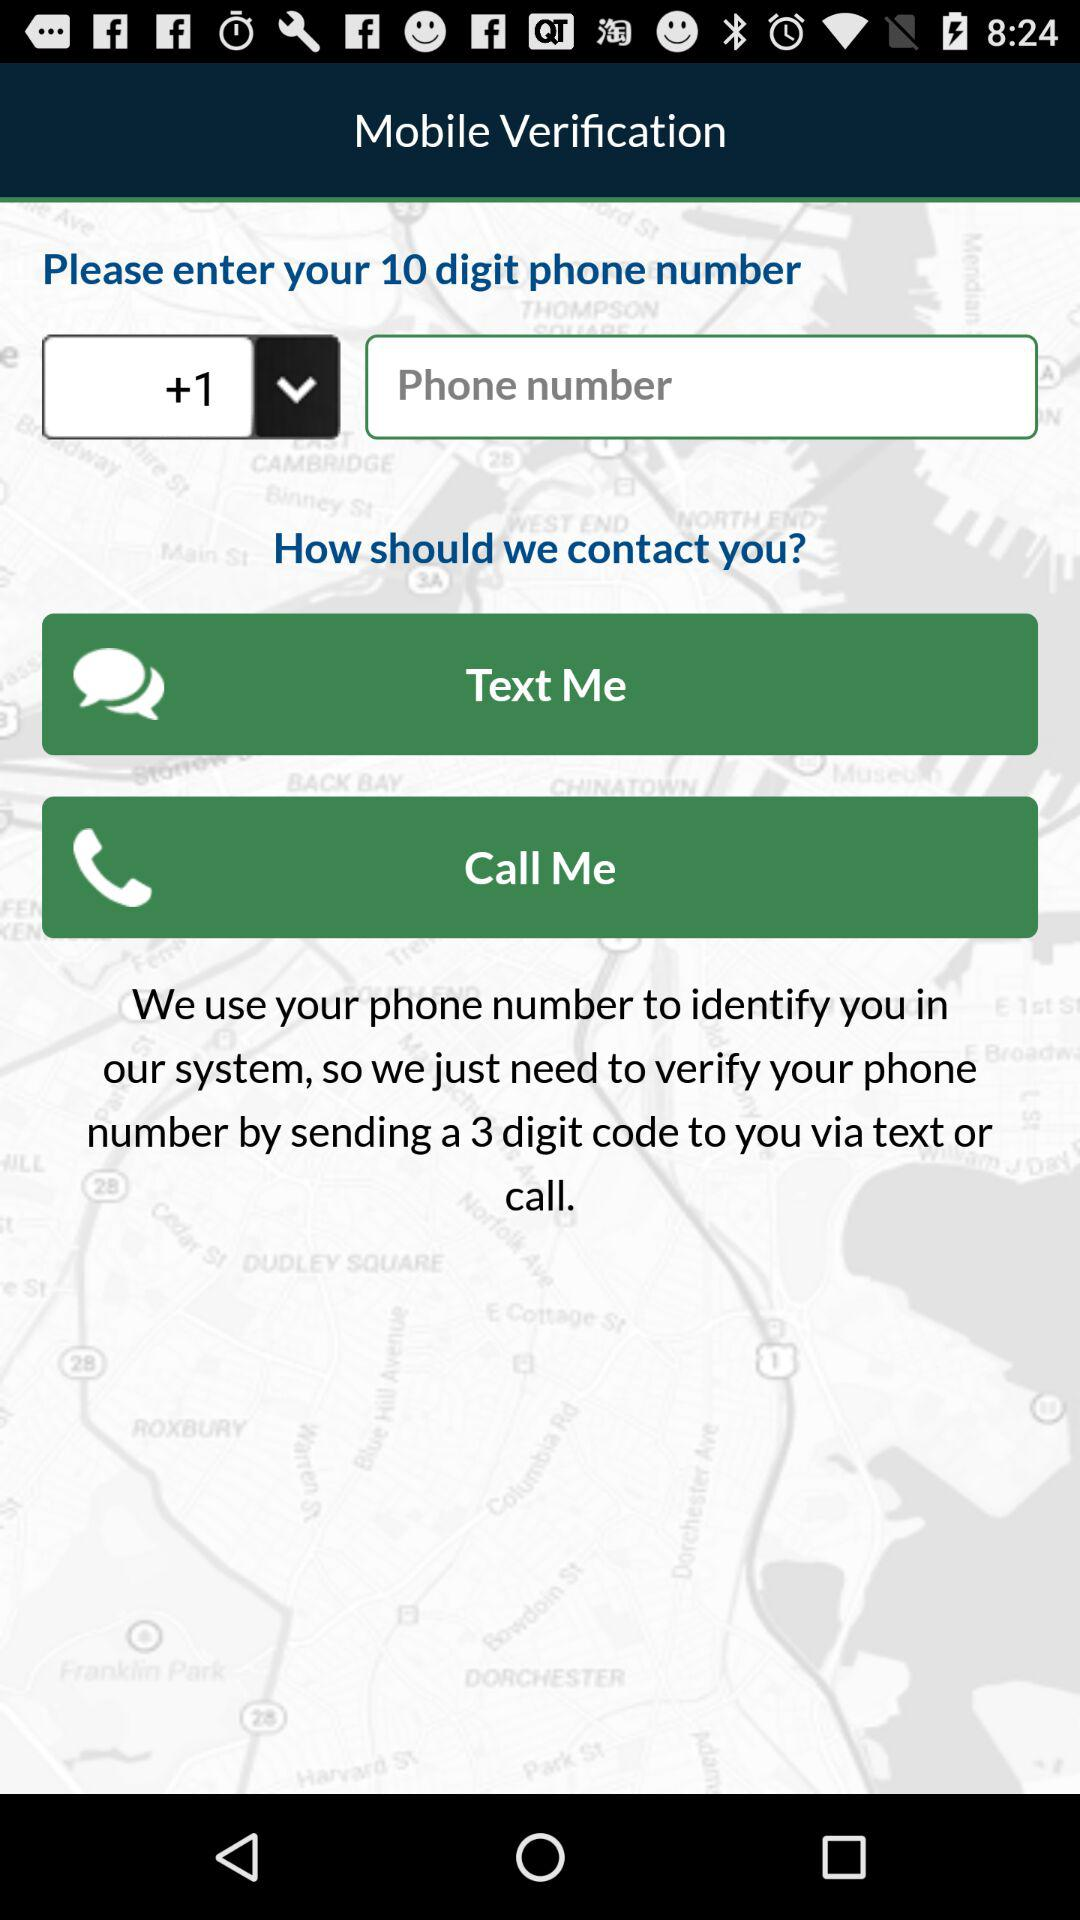What is the selected country code? The selected country code is +1. 